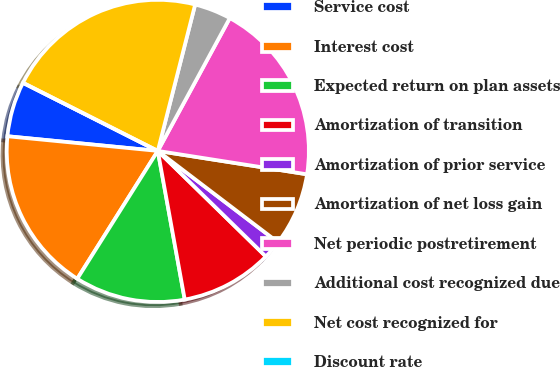Convert chart to OTSL. <chart><loc_0><loc_0><loc_500><loc_500><pie_chart><fcel>Service cost<fcel>Interest cost<fcel>Expected return on plan assets<fcel>Amortization of transition<fcel>Amortization of prior service<fcel>Amortization of net loss gain<fcel>Net periodic postretirement<fcel>Additional cost recognized due<fcel>Net cost recognized for<fcel>Discount rate<nl><fcel>5.9%<fcel>17.6%<fcel>11.8%<fcel>9.83%<fcel>1.97%<fcel>7.87%<fcel>19.57%<fcel>3.93%<fcel>21.53%<fcel>0.0%<nl></chart> 